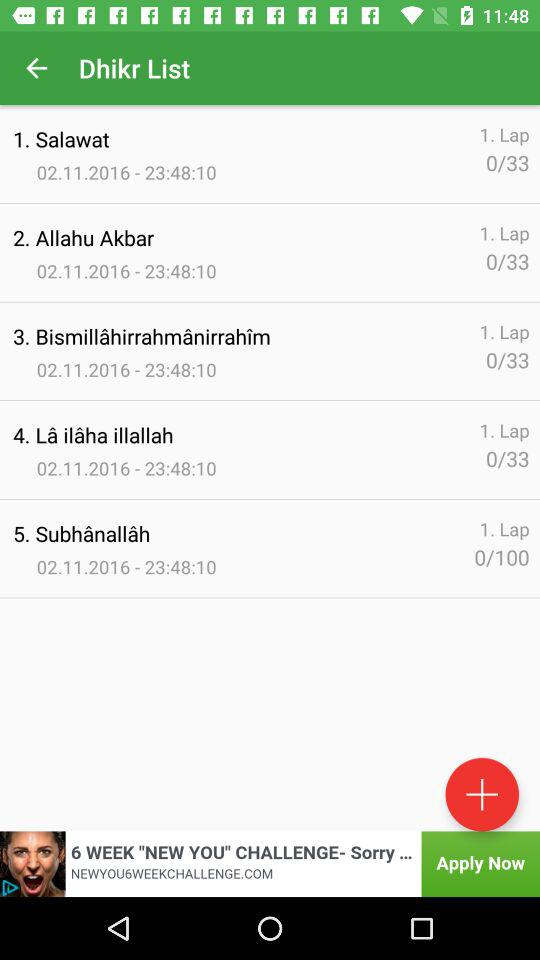How many laps are there in Allahu Akbar? There is 1 lap. 